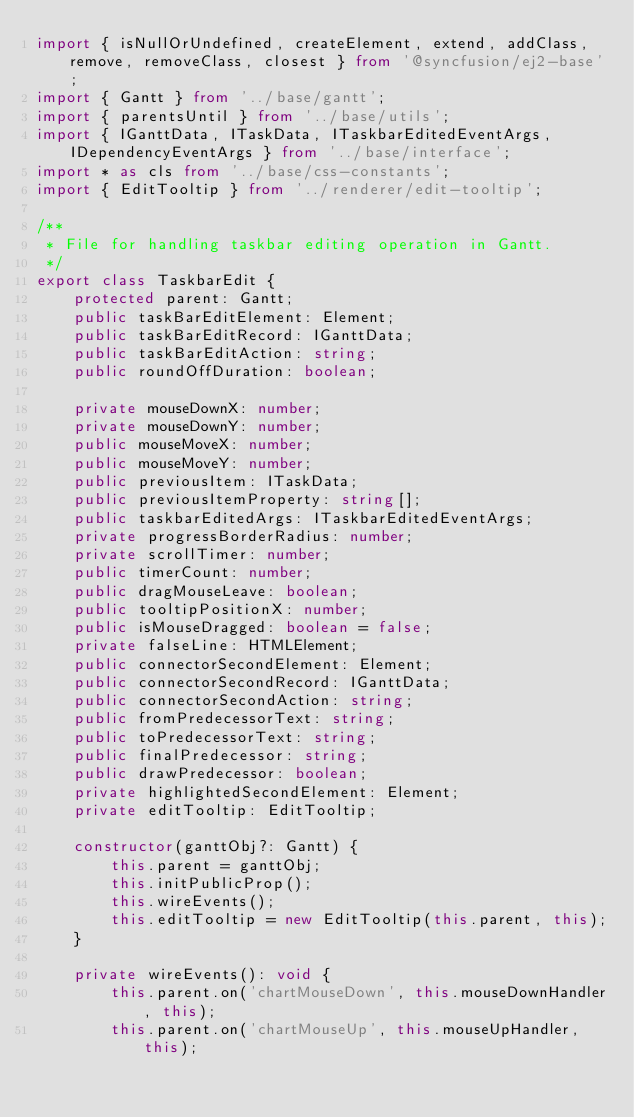<code> <loc_0><loc_0><loc_500><loc_500><_TypeScript_>import { isNullOrUndefined, createElement, extend, addClass, remove, removeClass, closest } from '@syncfusion/ej2-base';
import { Gantt } from '../base/gantt';
import { parentsUntil } from '../base/utils';
import { IGanttData, ITaskData, ITaskbarEditedEventArgs, IDependencyEventArgs } from '../base/interface';
import * as cls from '../base/css-constants';
import { EditTooltip } from '../renderer/edit-tooltip';

/**
 * File for handling taskbar editing operation in Gantt.
 */
export class TaskbarEdit {
    protected parent: Gantt;
    public taskBarEditElement: Element;
    public taskBarEditRecord: IGanttData;
    public taskBarEditAction: string;
    public roundOffDuration: boolean;

    private mouseDownX: number;
    private mouseDownY: number;
    public mouseMoveX: number;
    public mouseMoveY: number;
    public previousItem: ITaskData;
    public previousItemProperty: string[];
    public taskbarEditedArgs: ITaskbarEditedEventArgs;
    private progressBorderRadius: number;
    private scrollTimer: number;
    public timerCount: number;
    public dragMouseLeave: boolean;
    public tooltipPositionX: number;
    public isMouseDragged: boolean = false;
    private falseLine: HTMLElement;
    public connectorSecondElement: Element;
    public connectorSecondRecord: IGanttData;
    public connectorSecondAction: string;
    public fromPredecessorText: string;
    public toPredecessorText: string;
    public finalPredecessor: string;
    public drawPredecessor: boolean;
    private highlightedSecondElement: Element;
    private editTooltip: EditTooltip;

    constructor(ganttObj?: Gantt) {
        this.parent = ganttObj;
        this.initPublicProp();
        this.wireEvents();
        this.editTooltip = new EditTooltip(this.parent, this);
    }

    private wireEvents(): void {
        this.parent.on('chartMouseDown', this.mouseDownHandler, this);
        this.parent.on('chartMouseUp', this.mouseUpHandler, this);</code> 